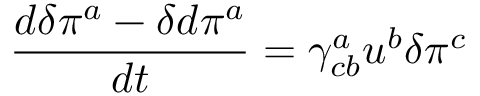Convert formula to latex. <formula><loc_0><loc_0><loc_500><loc_500>\frac { d \delta \pi ^ { a } - \delta d \pi ^ { a } } { d t } = \gamma _ { c b } ^ { a } u ^ { b } \delta \pi ^ { c }</formula> 